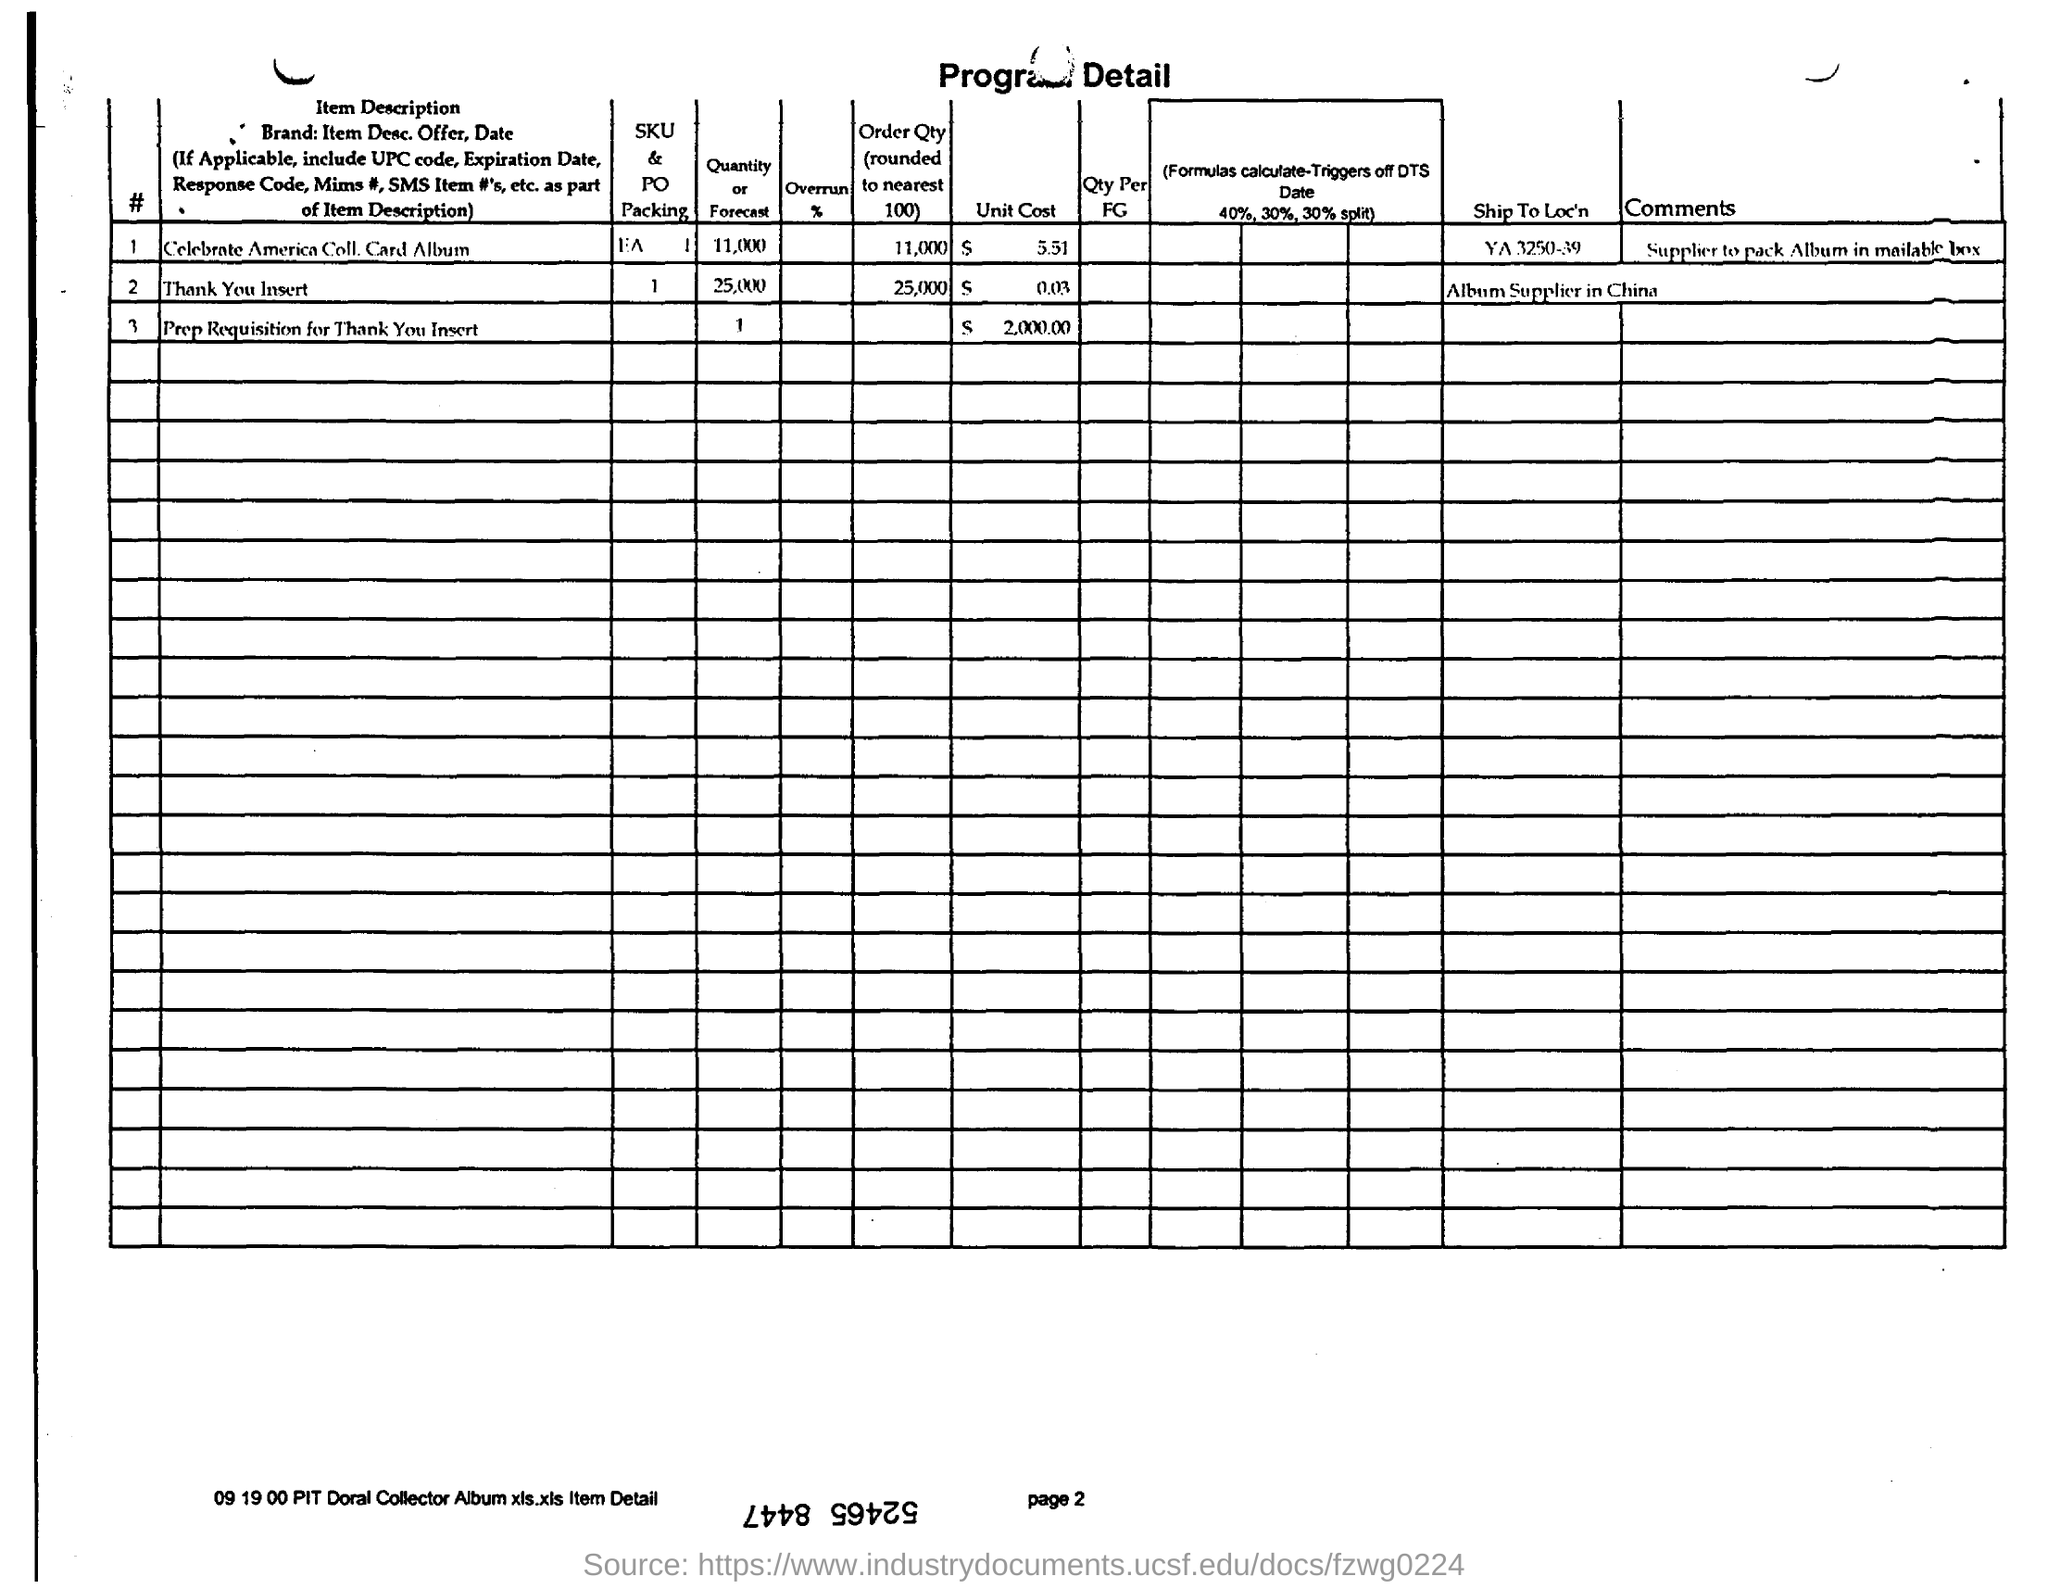What is the unit cost of  Celebrate America Coll. Card Album?
Offer a terse response. $ 5.51. How much is the order quantity for "Thank You Insert"?
Your answer should be very brief. 25000. 